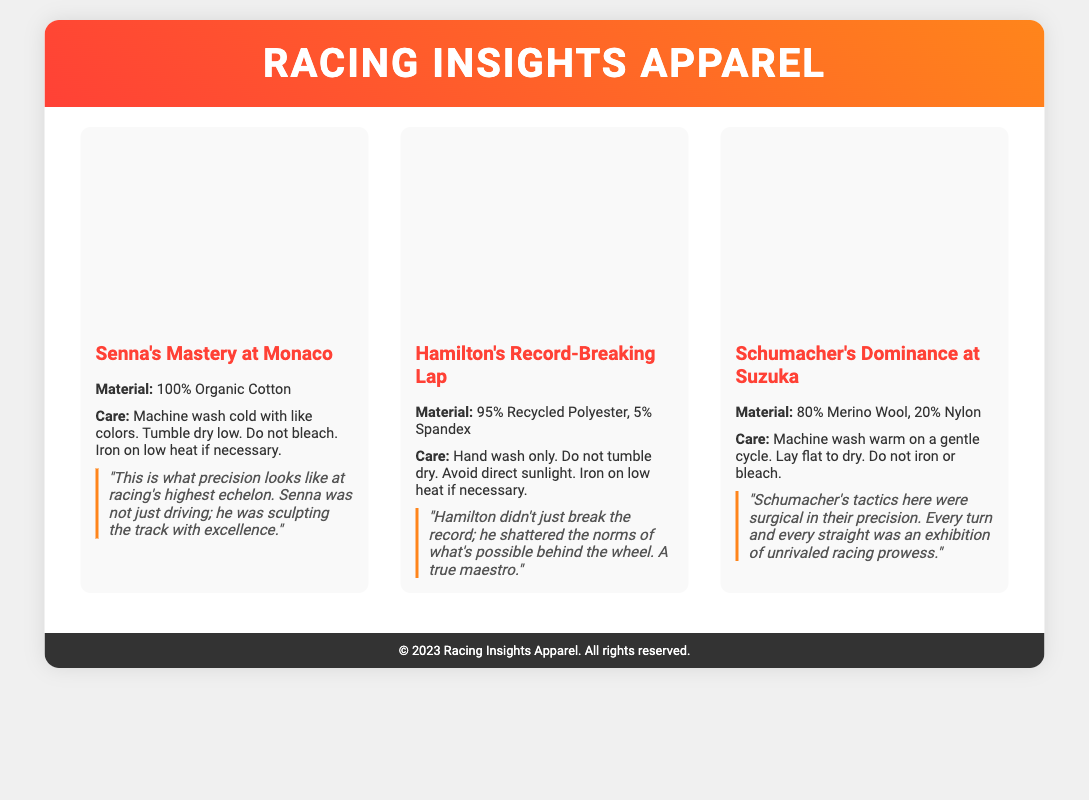what is the material of Senna's Mastery at Monaco? The document states that the material is 100% Organic Cotton.
Answer: 100% Organic Cotton what is the care instruction for Hamilton's Record-Breaking Lap? The care instruction specifies that it should be hand washed only, among other instructions.
Answer: Hand wash only how many products are displayed in the product grid? The document contains three product cards representing three items.
Answer: 3 what type of fabric is used in Schumacher's Dominance at Suzuka? The material composition includes Merino Wool and Nylon.
Answer: 80% Merino Wool, 20% Nylon what motivational phrase is mentioned for Hamilton's Record-Breaking Lap? The quote reflects on Hamilton's achievements and highlights him as a maestro.
Answer: "Hamilton didn't just break the record; he shattered the norms of what's possible behind the wheel." what are the washing instructions for Senna's Mastery at Monaco? The document specifies machine wash cold with like colors, among other instructions.
Answer: Machine wash cold with like colors what is the color of the header section? The header background features a gradient with two specific colors.
Answer: Linear gradient of red and orange what is the height of the product images? The document indicates a specific height for the product images used in the presentation.
Answer: 200px what year is printed in the footer? The footer mentions a specific year associated with the product line.
Answer: 2023 